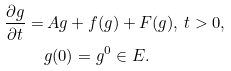Convert formula to latex. <formula><loc_0><loc_0><loc_500><loc_500>\frac { \partial g } { \partial t } = & \, A g + f ( g ) + F ( g ) , \, t > 0 , \\ & g ( 0 ) = g ^ { 0 } \in E .</formula> 